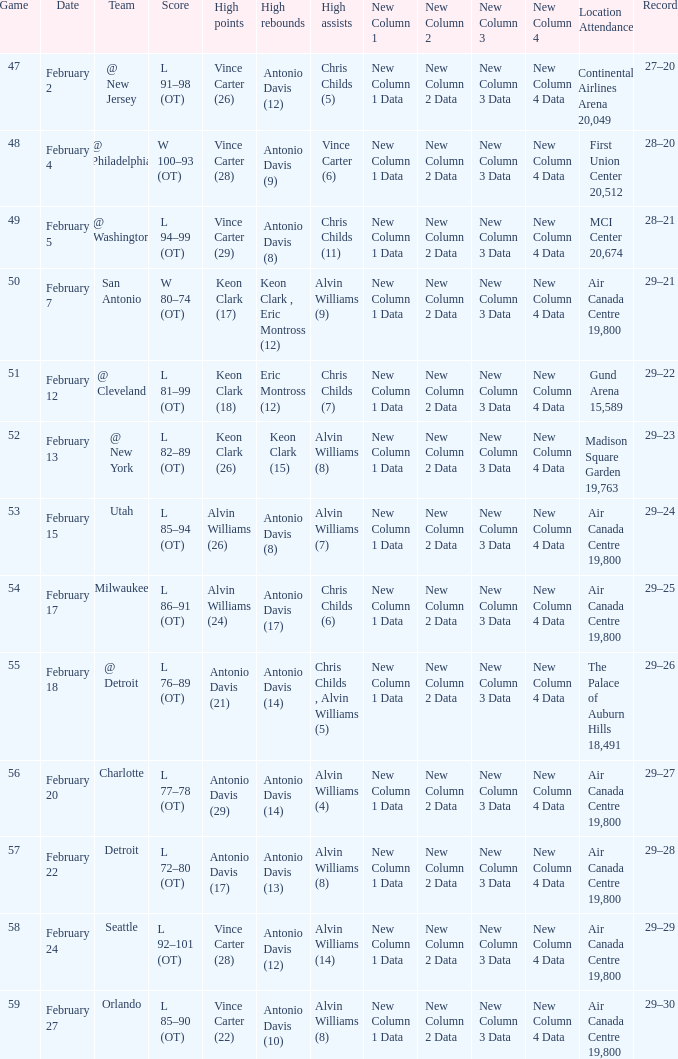Help me parse the entirety of this table. {'header': ['Game', 'Date', 'Team', 'Score', 'High points', 'High rebounds', 'High assists', 'New Column 1', 'New Column 2', 'New Column 3', 'New Column 4', 'Location Attendance', 'Record'], 'rows': [['47', 'February 2', '@ New Jersey', 'L 91–98 (OT)', 'Vince Carter (26)', 'Antonio Davis (12)', 'Chris Childs (5)', 'New Column 1 Data', 'New Column 2 Data', 'New Column 3 Data', 'New Column 4 Data', 'Continental Airlines Arena 20,049', '27–20'], ['48', 'February 4', '@ Philadelphia', 'W 100–93 (OT)', 'Vince Carter (28)', 'Antonio Davis (9)', 'Vince Carter (6)', 'New Column 1 Data', 'New Column 2 Data', 'New Column 3 Data', 'New Column 4 Data', 'First Union Center 20,512', '28–20'], ['49', 'February 5', '@ Washington', 'L 94–99 (OT)', 'Vince Carter (29)', 'Antonio Davis (8)', 'Chris Childs (11)', 'New Column 1 Data', 'New Column 2 Data', 'New Column 3 Data', 'New Column 4 Data', 'MCI Center 20,674', '28–21'], ['50', 'February 7', 'San Antonio', 'W 80–74 (OT)', 'Keon Clark (17)', 'Keon Clark , Eric Montross (12)', 'Alvin Williams (9)', 'New Column 1 Data', 'New Column 2 Data', 'New Column 3 Data', 'New Column 4 Data', 'Air Canada Centre 19,800', '29–21'], ['51', 'February 12', '@ Cleveland', 'L 81–99 (OT)', 'Keon Clark (18)', 'Eric Montross (12)', 'Chris Childs (7)', 'New Column 1 Data', 'New Column 2 Data', 'New Column 3 Data', 'New Column 4 Data', 'Gund Arena 15,589', '29–22'], ['52', 'February 13', '@ New York', 'L 82–89 (OT)', 'Keon Clark (26)', 'Keon Clark (15)', 'Alvin Williams (8)', 'New Column 1 Data', 'New Column 2 Data', 'New Column 3 Data', 'New Column 4 Data', 'Madison Square Garden 19,763', '29–23'], ['53', 'February 15', 'Utah', 'L 85–94 (OT)', 'Alvin Williams (26)', 'Antonio Davis (8)', 'Alvin Williams (7)', 'New Column 1 Data', 'New Column 2 Data', 'New Column 3 Data', 'New Column 4 Data', 'Air Canada Centre 19,800', '29–24'], ['54', 'February 17', 'Milwaukee', 'L 86–91 (OT)', 'Alvin Williams (24)', 'Antonio Davis (17)', 'Chris Childs (6)', 'New Column 1 Data', 'New Column 2 Data', 'New Column 3 Data', 'New Column 4 Data', 'Air Canada Centre 19,800', '29–25'], ['55', 'February 18', '@ Detroit', 'L 76–89 (OT)', 'Antonio Davis (21)', 'Antonio Davis (14)', 'Chris Childs , Alvin Williams (5)', 'New Column 1 Data', 'New Column 2 Data', 'New Column 3 Data', 'New Column 4 Data', 'The Palace of Auburn Hills 18,491', '29–26'], ['56', 'February 20', 'Charlotte', 'L 77–78 (OT)', 'Antonio Davis (29)', 'Antonio Davis (14)', 'Alvin Williams (4)', 'New Column 1 Data', 'New Column 2 Data', 'New Column 3 Data', 'New Column 4 Data', 'Air Canada Centre 19,800', '29–27'], ['57', 'February 22', 'Detroit', 'L 72–80 (OT)', 'Antonio Davis (17)', 'Antonio Davis (13)', 'Alvin Williams (8)', 'New Column 1 Data', 'New Column 2 Data', 'New Column 3 Data', 'New Column 4 Data', 'Air Canada Centre 19,800', '29–28'], ['58', 'February 24', 'Seattle', 'L 92–101 (OT)', 'Vince Carter (28)', 'Antonio Davis (12)', 'Alvin Williams (14)', 'New Column 1 Data', 'New Column 2 Data', 'New Column 3 Data', 'New Column 4 Data', 'Air Canada Centre 19,800', '29–29'], ['59', 'February 27', 'Orlando', 'L 85–90 (OT)', 'Vince Carter (22)', 'Antonio Davis (10)', 'Alvin Williams (8)', 'New Column 1 Data', 'New Column 2 Data', 'New Column 3 Data', 'New Column 4 Data', 'Air Canada Centre 19,800', '29–30']]} What is the Team with a game of more than 56, and the score is l 85–90 (ot)? Orlando. 